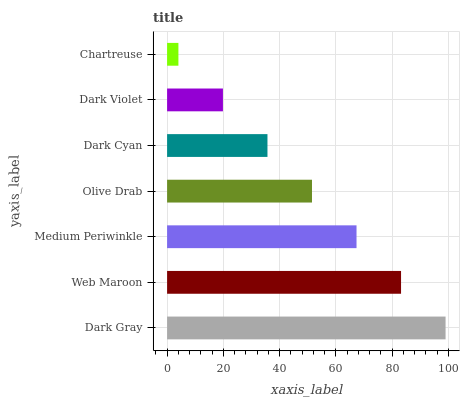Is Chartreuse the minimum?
Answer yes or no. Yes. Is Dark Gray the maximum?
Answer yes or no. Yes. Is Web Maroon the minimum?
Answer yes or no. No. Is Web Maroon the maximum?
Answer yes or no. No. Is Dark Gray greater than Web Maroon?
Answer yes or no. Yes. Is Web Maroon less than Dark Gray?
Answer yes or no. Yes. Is Web Maroon greater than Dark Gray?
Answer yes or no. No. Is Dark Gray less than Web Maroon?
Answer yes or no. No. Is Olive Drab the high median?
Answer yes or no. Yes. Is Olive Drab the low median?
Answer yes or no. Yes. Is Medium Periwinkle the high median?
Answer yes or no. No. Is Medium Periwinkle the low median?
Answer yes or no. No. 